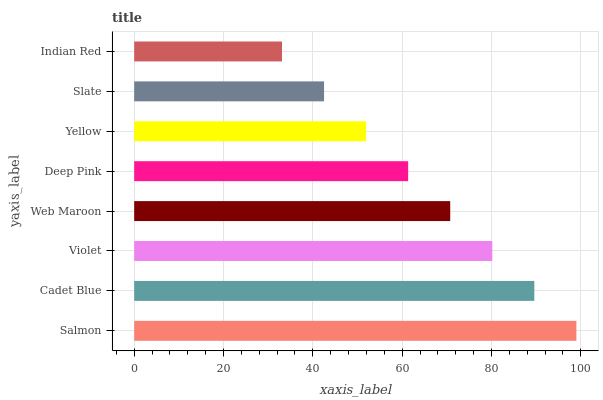Is Indian Red the minimum?
Answer yes or no. Yes. Is Salmon the maximum?
Answer yes or no. Yes. Is Cadet Blue the minimum?
Answer yes or no. No. Is Cadet Blue the maximum?
Answer yes or no. No. Is Salmon greater than Cadet Blue?
Answer yes or no. Yes. Is Cadet Blue less than Salmon?
Answer yes or no. Yes. Is Cadet Blue greater than Salmon?
Answer yes or no. No. Is Salmon less than Cadet Blue?
Answer yes or no. No. Is Web Maroon the high median?
Answer yes or no. Yes. Is Deep Pink the low median?
Answer yes or no. Yes. Is Cadet Blue the high median?
Answer yes or no. No. Is Violet the low median?
Answer yes or no. No. 